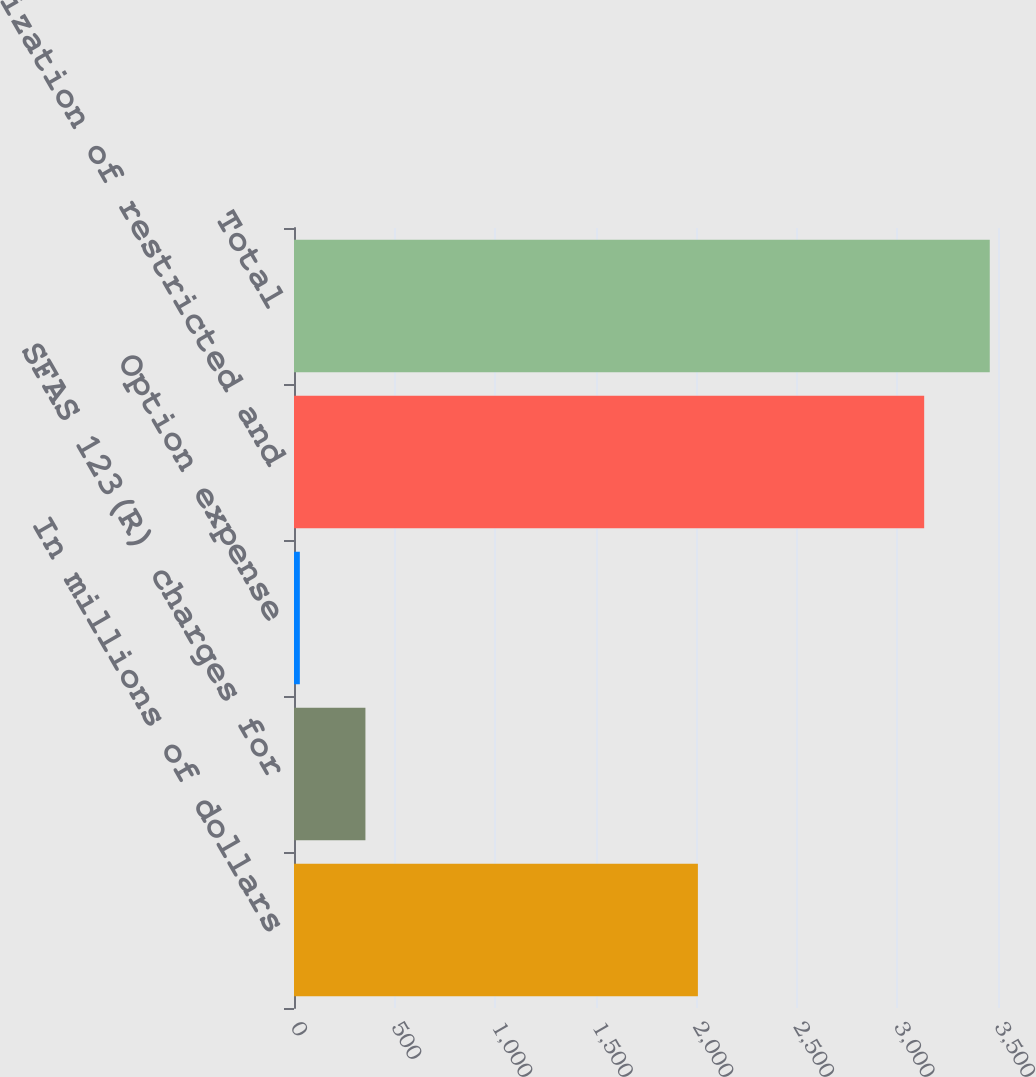Convert chart. <chart><loc_0><loc_0><loc_500><loc_500><bar_chart><fcel>In millions of dollars<fcel>SFAS 123(R) charges for<fcel>Option expense<fcel>Amortization of restricted and<fcel>Total<nl><fcel>2008<fcel>355.1<fcel>29<fcel>3133<fcel>3459.1<nl></chart> 